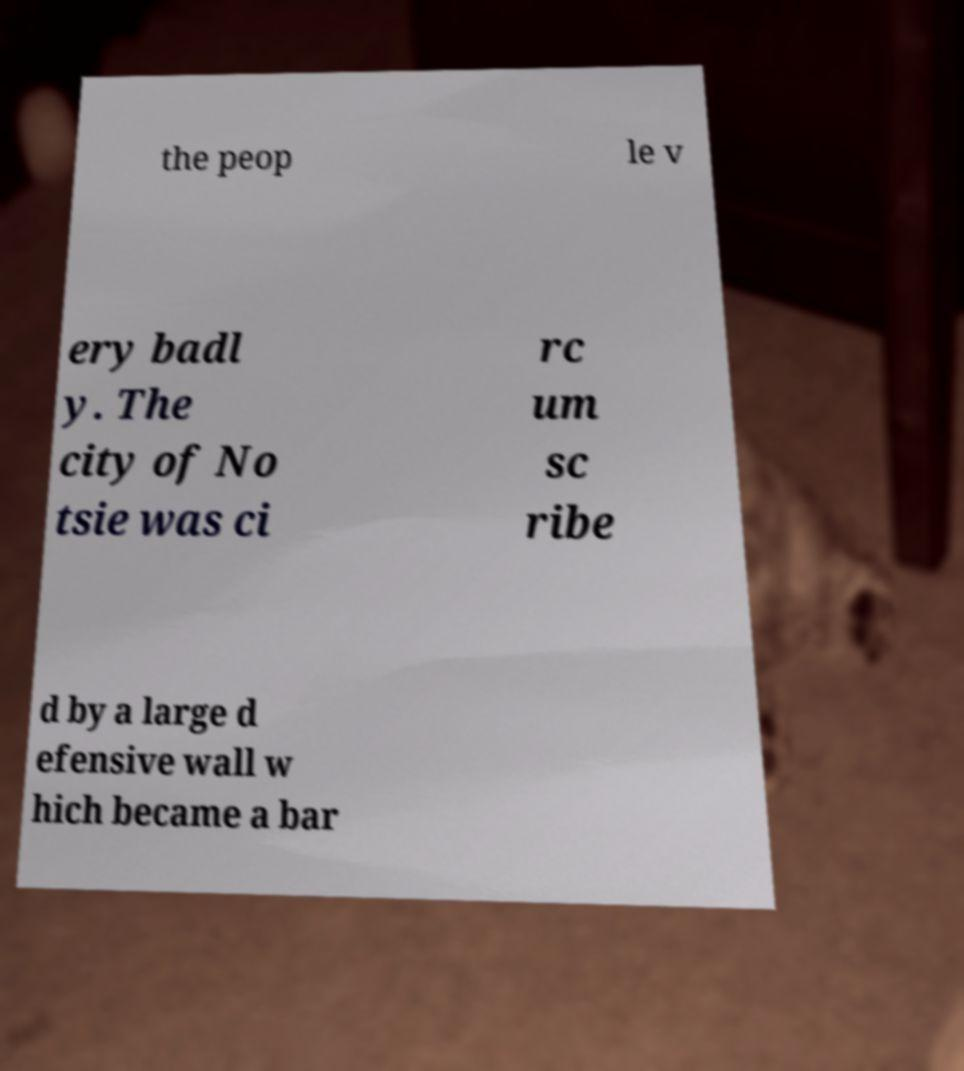For documentation purposes, I need the text within this image transcribed. Could you provide that? the peop le v ery badl y. The city of No tsie was ci rc um sc ribe d by a large d efensive wall w hich became a bar 